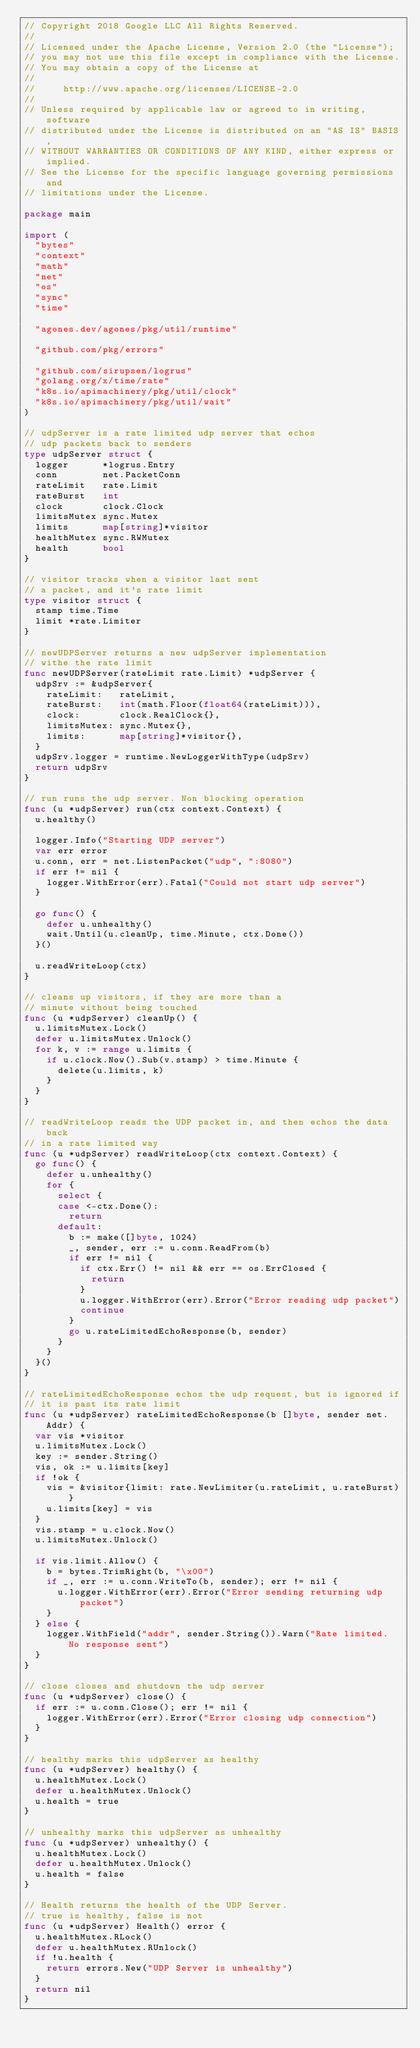<code> <loc_0><loc_0><loc_500><loc_500><_Go_>// Copyright 2018 Google LLC All Rights Reserved.
//
// Licensed under the Apache License, Version 2.0 (the "License");
// you may not use this file except in compliance with the License.
// You may obtain a copy of the License at
//
//     http://www.apache.org/licenses/LICENSE-2.0
//
// Unless required by applicable law or agreed to in writing, software
// distributed under the License is distributed on an "AS IS" BASIS,
// WITHOUT WARRANTIES OR CONDITIONS OF ANY KIND, either express or implied.
// See the License for the specific language governing permissions and
// limitations under the License.

package main

import (
	"bytes"
	"context"
	"math"
	"net"
	"os"
	"sync"
	"time"

	"agones.dev/agones/pkg/util/runtime"

	"github.com/pkg/errors"

	"github.com/sirupsen/logrus"
	"golang.org/x/time/rate"
	"k8s.io/apimachinery/pkg/util/clock"
	"k8s.io/apimachinery/pkg/util/wait"
)

// udpServer is a rate limited udp server that echos
// udp packets back to senders
type udpServer struct {
	logger      *logrus.Entry
	conn        net.PacketConn
	rateLimit   rate.Limit
	rateBurst   int
	clock       clock.Clock
	limitsMutex sync.Mutex
	limits      map[string]*visitor
	healthMutex sync.RWMutex
	health      bool
}

// visitor tracks when a visitor last sent
// a packet, and it's rate limit
type visitor struct {
	stamp time.Time
	limit *rate.Limiter
}

// newUDPServer returns a new udpServer implementation
// withe the rate limit
func newUDPServer(rateLimit rate.Limit) *udpServer {
	udpSrv := &udpServer{
		rateLimit:   rateLimit,
		rateBurst:   int(math.Floor(float64(rateLimit))),
		clock:       clock.RealClock{},
		limitsMutex: sync.Mutex{},
		limits:      map[string]*visitor{},
	}
	udpSrv.logger = runtime.NewLoggerWithType(udpSrv)
	return udpSrv
}

// run runs the udp server. Non blocking operation
func (u *udpServer) run(ctx context.Context) {
	u.healthy()

	logger.Info("Starting UDP server")
	var err error
	u.conn, err = net.ListenPacket("udp", ":8080")
	if err != nil {
		logger.WithError(err).Fatal("Could not start udp server")
	}

	go func() {
		defer u.unhealthy()
		wait.Until(u.cleanUp, time.Minute, ctx.Done())
	}()

	u.readWriteLoop(ctx)
}

// cleans up visitors, if they are more than a
// minute without being touched
func (u *udpServer) cleanUp() {
	u.limitsMutex.Lock()
	defer u.limitsMutex.Unlock()
	for k, v := range u.limits {
		if u.clock.Now().Sub(v.stamp) > time.Minute {
			delete(u.limits, k)
		}
	}
}

// readWriteLoop reads the UDP packet in, and then echos the data back
// in a rate limited way
func (u *udpServer) readWriteLoop(ctx context.Context) {
	go func() {
		defer u.unhealthy()
		for {
			select {
			case <-ctx.Done():
				return
			default:
				b := make([]byte, 1024)
				_, sender, err := u.conn.ReadFrom(b)
				if err != nil {
					if ctx.Err() != nil && err == os.ErrClosed {
						return
					}
					u.logger.WithError(err).Error("Error reading udp packet")
					continue
				}
				go u.rateLimitedEchoResponse(b, sender)
			}
		}
	}()
}

// rateLimitedEchoResponse echos the udp request, but is ignored if
// it is past its rate limit
func (u *udpServer) rateLimitedEchoResponse(b []byte, sender net.Addr) {
	var vis *visitor
	u.limitsMutex.Lock()
	key := sender.String()
	vis, ok := u.limits[key]
	if !ok {
		vis = &visitor{limit: rate.NewLimiter(u.rateLimit, u.rateBurst)}
		u.limits[key] = vis
	}
	vis.stamp = u.clock.Now()
	u.limitsMutex.Unlock()

	if vis.limit.Allow() {
		b = bytes.TrimRight(b, "\x00")
		if _, err := u.conn.WriteTo(b, sender); err != nil {
			u.logger.WithError(err).Error("Error sending returning udp packet")
		}
	} else {
		logger.WithField("addr", sender.String()).Warn("Rate limited. No response sent")
	}
}

// close closes and shutdown the udp server
func (u *udpServer) close() {
	if err := u.conn.Close(); err != nil {
		logger.WithError(err).Error("Error closing udp connection")
	}
}

// healthy marks this udpServer as healthy
func (u *udpServer) healthy() {
	u.healthMutex.Lock()
	defer u.healthMutex.Unlock()
	u.health = true
}

// unhealthy marks this udpServer as unhealthy
func (u *udpServer) unhealthy() {
	u.healthMutex.Lock()
	defer u.healthMutex.Unlock()
	u.health = false
}

// Health returns the health of the UDP Server.
// true is healthy, false is not
func (u *udpServer) Health() error {
	u.healthMutex.RLock()
	defer u.healthMutex.RUnlock()
	if !u.health {
		return errors.New("UDP Server is unhealthy")
	}
	return nil
}
</code> 